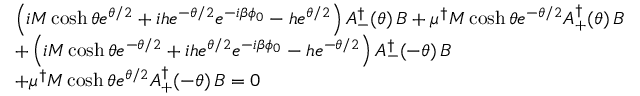<formula> <loc_0><loc_0><loc_500><loc_500>\begin{array} { l l & { { \left ( i M \cosh \theta e ^ { \theta / 2 } + i h e ^ { - \theta / 2 } e ^ { - i \beta \phi _ { 0 } } - h e ^ { \theta / 2 } \right ) A _ { - } ^ { \dagger } ( \theta ) \, B + \mu ^ { \dagger } M \cosh \theta e ^ { - \theta / 2 } A _ { + } ^ { \dagger } ( \theta ) \, B } } & { { + \left ( i M \cosh \theta e ^ { - \theta / 2 } + i h e ^ { \theta / 2 } e ^ { - i \beta \phi _ { 0 } } - h e ^ { - \theta / 2 } \right ) A _ { - } ^ { \dagger } ( - \theta ) \, B } } & { { + \mu ^ { \dagger } M \cosh \theta e ^ { \theta / 2 } A _ { + } ^ { \dagger } ( - \theta ) \, B = 0 } } \end{array}</formula> 